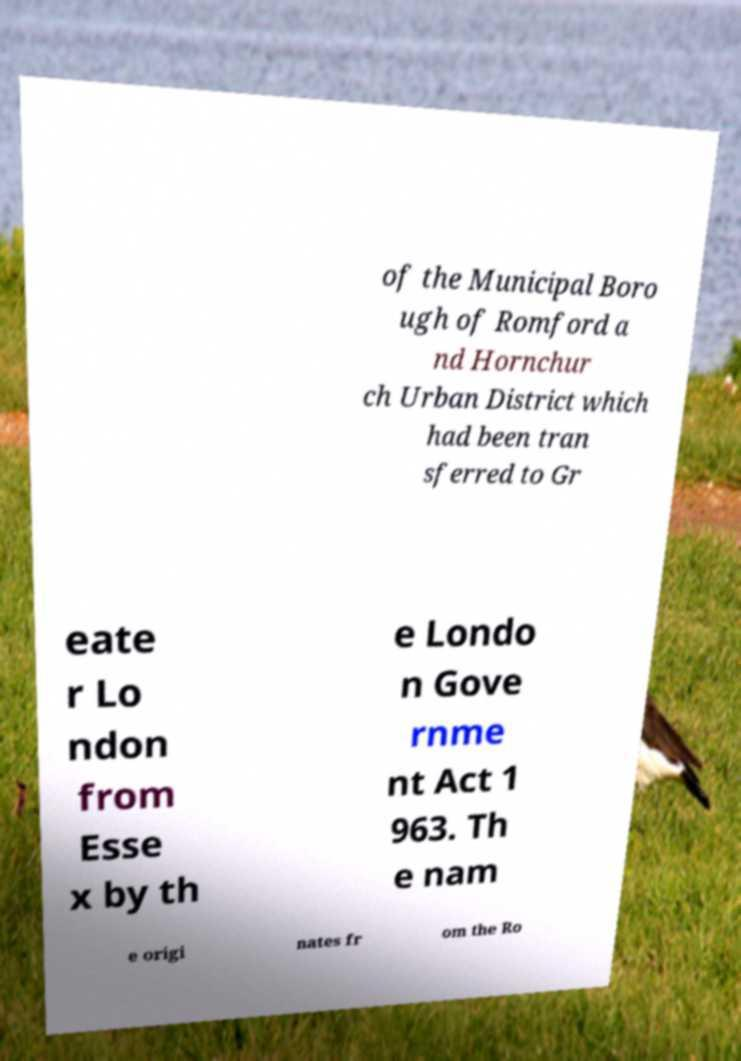For documentation purposes, I need the text within this image transcribed. Could you provide that? of the Municipal Boro ugh of Romford a nd Hornchur ch Urban District which had been tran sferred to Gr eate r Lo ndon from Esse x by th e Londo n Gove rnme nt Act 1 963. Th e nam e origi nates fr om the Ro 